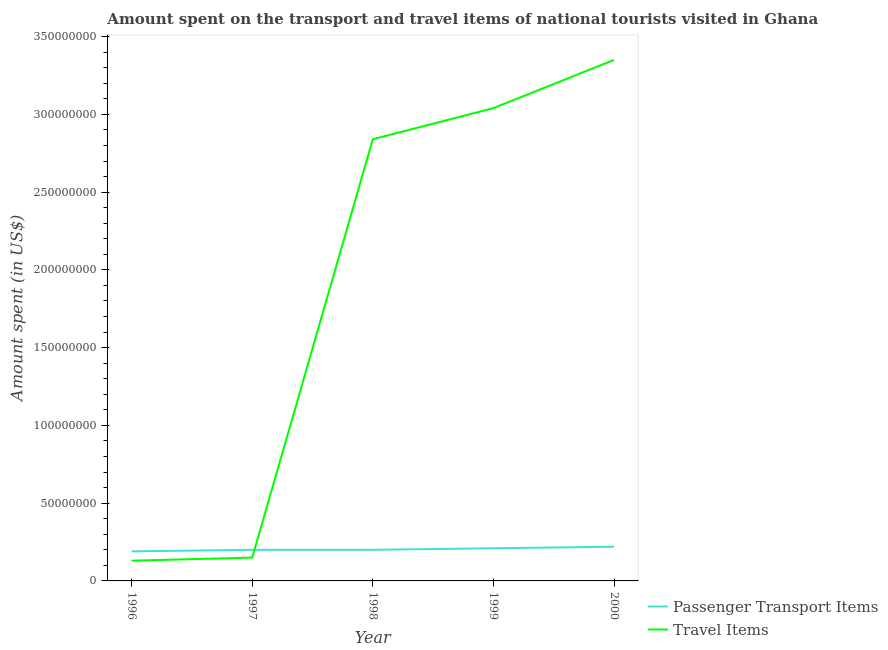How many different coloured lines are there?
Offer a very short reply. 2. What is the amount spent in travel items in 1997?
Keep it short and to the point. 1.50e+07. Across all years, what is the maximum amount spent on passenger transport items?
Your answer should be very brief. 2.20e+07. Across all years, what is the minimum amount spent on passenger transport items?
Give a very brief answer. 1.90e+07. What is the total amount spent on passenger transport items in the graph?
Give a very brief answer. 1.02e+08. What is the difference between the amount spent in travel items in 1997 and that in 1999?
Give a very brief answer. -2.89e+08. What is the difference between the amount spent in travel items in 1998 and the amount spent on passenger transport items in 2000?
Offer a very short reply. 2.62e+08. What is the average amount spent in travel items per year?
Your answer should be very brief. 1.90e+08. In the year 1996, what is the difference between the amount spent in travel items and amount spent on passenger transport items?
Provide a short and direct response. -6.00e+06. What is the ratio of the amount spent on passenger transport items in 1997 to that in 1998?
Your response must be concise. 1. Is the amount spent in travel items in 1998 less than that in 2000?
Provide a succinct answer. Yes. What is the difference between the highest and the second highest amount spent in travel items?
Give a very brief answer. 3.10e+07. What is the difference between the highest and the lowest amount spent on passenger transport items?
Your answer should be very brief. 3.00e+06. Is the sum of the amount spent on passenger transport items in 1996 and 1998 greater than the maximum amount spent in travel items across all years?
Give a very brief answer. No. Does the amount spent on passenger transport items monotonically increase over the years?
Give a very brief answer. No. How many lines are there?
Keep it short and to the point. 2. What is the title of the graph?
Provide a short and direct response. Amount spent on the transport and travel items of national tourists visited in Ghana. Does "Secondary Education" appear as one of the legend labels in the graph?
Your answer should be compact. No. What is the label or title of the X-axis?
Offer a very short reply. Year. What is the label or title of the Y-axis?
Keep it short and to the point. Amount spent (in US$). What is the Amount spent (in US$) of Passenger Transport Items in 1996?
Keep it short and to the point. 1.90e+07. What is the Amount spent (in US$) in Travel Items in 1996?
Your response must be concise. 1.30e+07. What is the Amount spent (in US$) in Travel Items in 1997?
Make the answer very short. 1.50e+07. What is the Amount spent (in US$) of Passenger Transport Items in 1998?
Your answer should be compact. 2.00e+07. What is the Amount spent (in US$) in Travel Items in 1998?
Make the answer very short. 2.84e+08. What is the Amount spent (in US$) of Passenger Transport Items in 1999?
Your response must be concise. 2.10e+07. What is the Amount spent (in US$) of Travel Items in 1999?
Your response must be concise. 3.04e+08. What is the Amount spent (in US$) in Passenger Transport Items in 2000?
Offer a terse response. 2.20e+07. What is the Amount spent (in US$) in Travel Items in 2000?
Your answer should be compact. 3.35e+08. Across all years, what is the maximum Amount spent (in US$) of Passenger Transport Items?
Make the answer very short. 2.20e+07. Across all years, what is the maximum Amount spent (in US$) in Travel Items?
Offer a terse response. 3.35e+08. Across all years, what is the minimum Amount spent (in US$) in Passenger Transport Items?
Your answer should be compact. 1.90e+07. Across all years, what is the minimum Amount spent (in US$) in Travel Items?
Ensure brevity in your answer.  1.30e+07. What is the total Amount spent (in US$) of Passenger Transport Items in the graph?
Offer a very short reply. 1.02e+08. What is the total Amount spent (in US$) of Travel Items in the graph?
Offer a very short reply. 9.51e+08. What is the difference between the Amount spent (in US$) of Passenger Transport Items in 1996 and that in 1997?
Your response must be concise. -1.00e+06. What is the difference between the Amount spent (in US$) in Travel Items in 1996 and that in 1998?
Offer a very short reply. -2.71e+08. What is the difference between the Amount spent (in US$) in Passenger Transport Items in 1996 and that in 1999?
Offer a terse response. -2.00e+06. What is the difference between the Amount spent (in US$) in Travel Items in 1996 and that in 1999?
Provide a short and direct response. -2.91e+08. What is the difference between the Amount spent (in US$) of Passenger Transport Items in 1996 and that in 2000?
Offer a terse response. -3.00e+06. What is the difference between the Amount spent (in US$) of Travel Items in 1996 and that in 2000?
Offer a very short reply. -3.22e+08. What is the difference between the Amount spent (in US$) in Travel Items in 1997 and that in 1998?
Make the answer very short. -2.69e+08. What is the difference between the Amount spent (in US$) of Travel Items in 1997 and that in 1999?
Offer a very short reply. -2.89e+08. What is the difference between the Amount spent (in US$) in Passenger Transport Items in 1997 and that in 2000?
Offer a very short reply. -2.00e+06. What is the difference between the Amount spent (in US$) in Travel Items in 1997 and that in 2000?
Ensure brevity in your answer.  -3.20e+08. What is the difference between the Amount spent (in US$) in Passenger Transport Items in 1998 and that in 1999?
Keep it short and to the point. -1.00e+06. What is the difference between the Amount spent (in US$) in Travel Items in 1998 and that in 1999?
Keep it short and to the point. -2.00e+07. What is the difference between the Amount spent (in US$) in Passenger Transport Items in 1998 and that in 2000?
Your response must be concise. -2.00e+06. What is the difference between the Amount spent (in US$) of Travel Items in 1998 and that in 2000?
Offer a very short reply. -5.10e+07. What is the difference between the Amount spent (in US$) in Passenger Transport Items in 1999 and that in 2000?
Offer a terse response. -1.00e+06. What is the difference between the Amount spent (in US$) in Travel Items in 1999 and that in 2000?
Ensure brevity in your answer.  -3.10e+07. What is the difference between the Amount spent (in US$) in Passenger Transport Items in 1996 and the Amount spent (in US$) in Travel Items in 1997?
Ensure brevity in your answer.  4.00e+06. What is the difference between the Amount spent (in US$) of Passenger Transport Items in 1996 and the Amount spent (in US$) of Travel Items in 1998?
Your response must be concise. -2.65e+08. What is the difference between the Amount spent (in US$) in Passenger Transport Items in 1996 and the Amount spent (in US$) in Travel Items in 1999?
Offer a very short reply. -2.85e+08. What is the difference between the Amount spent (in US$) in Passenger Transport Items in 1996 and the Amount spent (in US$) in Travel Items in 2000?
Provide a short and direct response. -3.16e+08. What is the difference between the Amount spent (in US$) in Passenger Transport Items in 1997 and the Amount spent (in US$) in Travel Items in 1998?
Provide a succinct answer. -2.64e+08. What is the difference between the Amount spent (in US$) in Passenger Transport Items in 1997 and the Amount spent (in US$) in Travel Items in 1999?
Offer a very short reply. -2.84e+08. What is the difference between the Amount spent (in US$) of Passenger Transport Items in 1997 and the Amount spent (in US$) of Travel Items in 2000?
Provide a succinct answer. -3.15e+08. What is the difference between the Amount spent (in US$) of Passenger Transport Items in 1998 and the Amount spent (in US$) of Travel Items in 1999?
Give a very brief answer. -2.84e+08. What is the difference between the Amount spent (in US$) in Passenger Transport Items in 1998 and the Amount spent (in US$) in Travel Items in 2000?
Your answer should be compact. -3.15e+08. What is the difference between the Amount spent (in US$) of Passenger Transport Items in 1999 and the Amount spent (in US$) of Travel Items in 2000?
Keep it short and to the point. -3.14e+08. What is the average Amount spent (in US$) of Passenger Transport Items per year?
Your response must be concise. 2.04e+07. What is the average Amount spent (in US$) in Travel Items per year?
Your answer should be compact. 1.90e+08. In the year 1996, what is the difference between the Amount spent (in US$) of Passenger Transport Items and Amount spent (in US$) of Travel Items?
Keep it short and to the point. 6.00e+06. In the year 1997, what is the difference between the Amount spent (in US$) of Passenger Transport Items and Amount spent (in US$) of Travel Items?
Offer a terse response. 5.00e+06. In the year 1998, what is the difference between the Amount spent (in US$) in Passenger Transport Items and Amount spent (in US$) in Travel Items?
Your answer should be very brief. -2.64e+08. In the year 1999, what is the difference between the Amount spent (in US$) in Passenger Transport Items and Amount spent (in US$) in Travel Items?
Give a very brief answer. -2.83e+08. In the year 2000, what is the difference between the Amount spent (in US$) of Passenger Transport Items and Amount spent (in US$) of Travel Items?
Make the answer very short. -3.13e+08. What is the ratio of the Amount spent (in US$) of Travel Items in 1996 to that in 1997?
Ensure brevity in your answer.  0.87. What is the ratio of the Amount spent (in US$) in Passenger Transport Items in 1996 to that in 1998?
Provide a short and direct response. 0.95. What is the ratio of the Amount spent (in US$) in Travel Items in 1996 to that in 1998?
Offer a terse response. 0.05. What is the ratio of the Amount spent (in US$) of Passenger Transport Items in 1996 to that in 1999?
Your answer should be very brief. 0.9. What is the ratio of the Amount spent (in US$) in Travel Items in 1996 to that in 1999?
Your answer should be compact. 0.04. What is the ratio of the Amount spent (in US$) of Passenger Transport Items in 1996 to that in 2000?
Keep it short and to the point. 0.86. What is the ratio of the Amount spent (in US$) of Travel Items in 1996 to that in 2000?
Offer a very short reply. 0.04. What is the ratio of the Amount spent (in US$) in Travel Items in 1997 to that in 1998?
Make the answer very short. 0.05. What is the ratio of the Amount spent (in US$) of Passenger Transport Items in 1997 to that in 1999?
Provide a succinct answer. 0.95. What is the ratio of the Amount spent (in US$) in Travel Items in 1997 to that in 1999?
Ensure brevity in your answer.  0.05. What is the ratio of the Amount spent (in US$) of Passenger Transport Items in 1997 to that in 2000?
Your response must be concise. 0.91. What is the ratio of the Amount spent (in US$) of Travel Items in 1997 to that in 2000?
Provide a succinct answer. 0.04. What is the ratio of the Amount spent (in US$) in Passenger Transport Items in 1998 to that in 1999?
Your response must be concise. 0.95. What is the ratio of the Amount spent (in US$) in Travel Items in 1998 to that in 1999?
Provide a succinct answer. 0.93. What is the ratio of the Amount spent (in US$) in Travel Items in 1998 to that in 2000?
Give a very brief answer. 0.85. What is the ratio of the Amount spent (in US$) in Passenger Transport Items in 1999 to that in 2000?
Offer a terse response. 0.95. What is the ratio of the Amount spent (in US$) in Travel Items in 1999 to that in 2000?
Ensure brevity in your answer.  0.91. What is the difference between the highest and the second highest Amount spent (in US$) in Passenger Transport Items?
Provide a short and direct response. 1.00e+06. What is the difference between the highest and the second highest Amount spent (in US$) of Travel Items?
Give a very brief answer. 3.10e+07. What is the difference between the highest and the lowest Amount spent (in US$) in Passenger Transport Items?
Make the answer very short. 3.00e+06. What is the difference between the highest and the lowest Amount spent (in US$) in Travel Items?
Your answer should be very brief. 3.22e+08. 